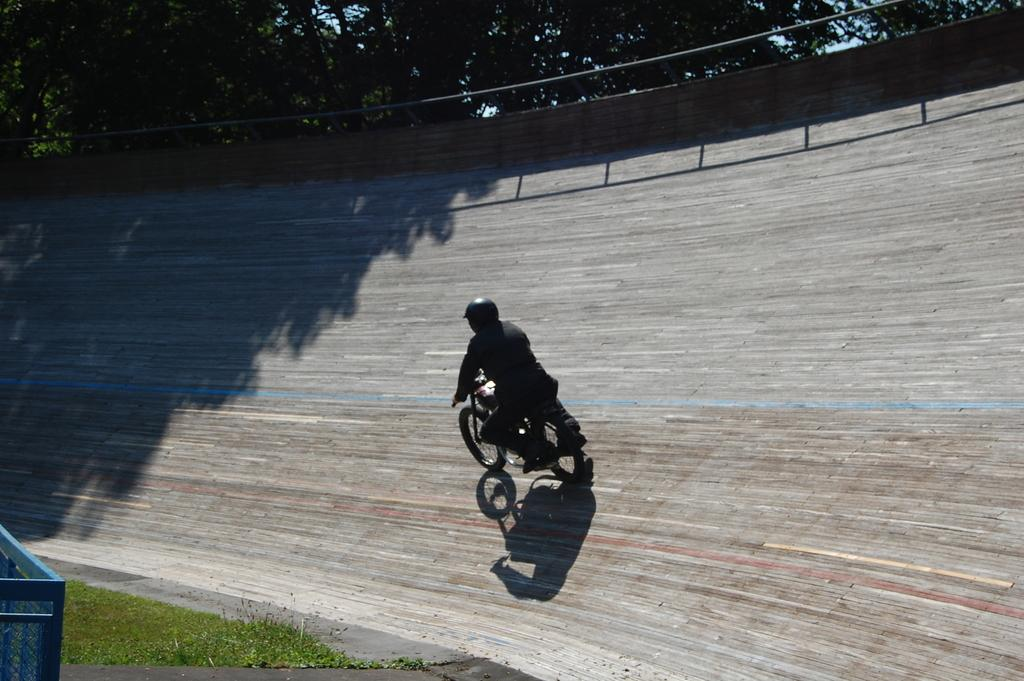What is the main subject of the image? There is a person in the image. What is the person doing in the image? The person is riding a bike. What can be seen in the background of the image? There are trees in the background of the image. What type of gold jewelry is the person wearing in the image? There is no mention of gold jewelry in the image, and the person's attire is not described. 